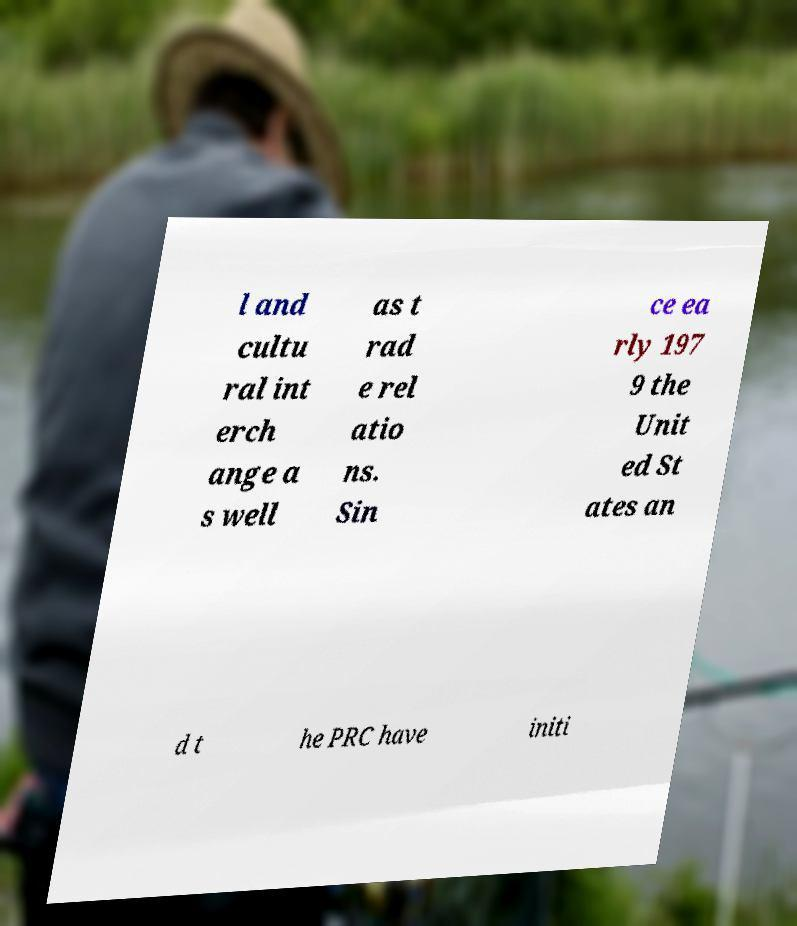What messages or text are displayed in this image? I need them in a readable, typed format. l and cultu ral int erch ange a s well as t rad e rel atio ns. Sin ce ea rly 197 9 the Unit ed St ates an d t he PRC have initi 